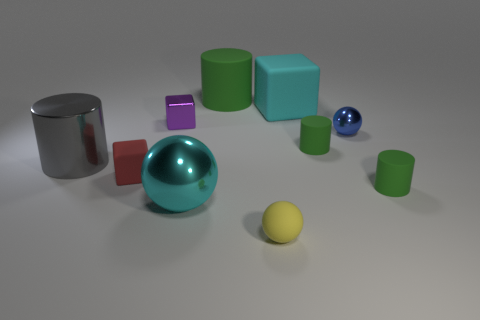Subtract all yellow blocks. How many green cylinders are left? 3 Subtract 1 cylinders. How many cylinders are left? 3 Subtract all rubber cylinders. How many cylinders are left? 1 Subtract all purple cylinders. Subtract all gray spheres. How many cylinders are left? 4 Subtract all cubes. How many objects are left? 7 Add 1 gray things. How many gray things exist? 2 Subtract 0 purple balls. How many objects are left? 10 Subtract all large brown metal things. Subtract all green cylinders. How many objects are left? 7 Add 9 gray things. How many gray things are left? 10 